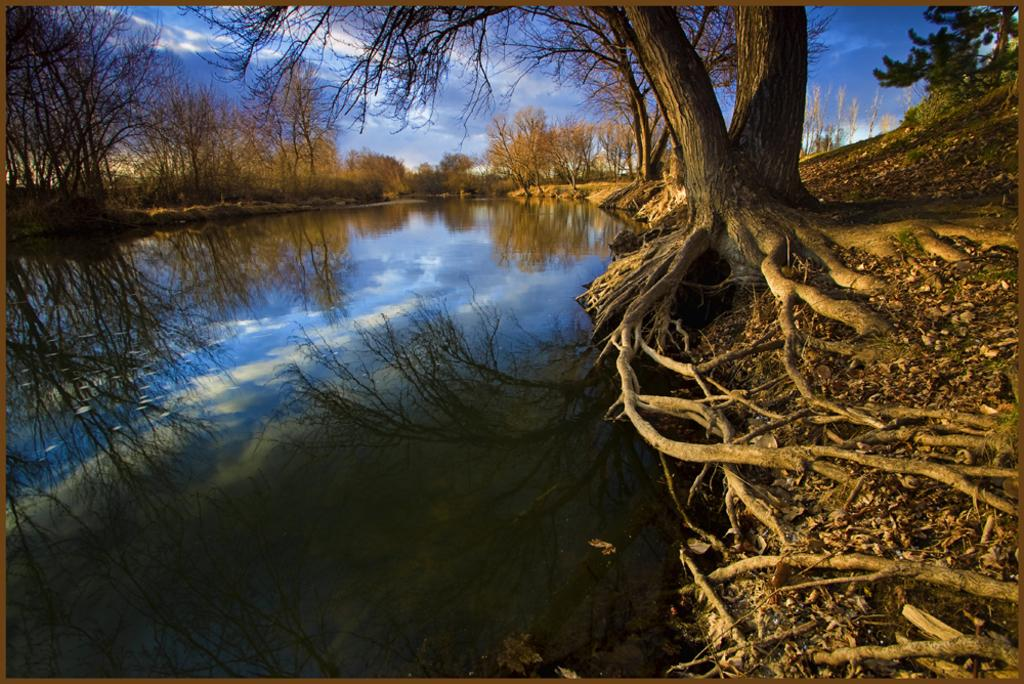What is the main element present in the image? There is water in the image. What can be seen on the ground to the right side of the image? There are trees on the ground to the right. What is visible in the background of the image? There are trees in the background. What is visible at the top of the image? The sky is visible at the top of the image. How many jellyfish can be seen swimming in the water in the image? There are no jellyfish present in the image; it only features water, trees, and the sky. What type of string is used to tie the trees together in the image? There is no string or any indication of tied trees in the image; it only features trees on the ground and in the background. 